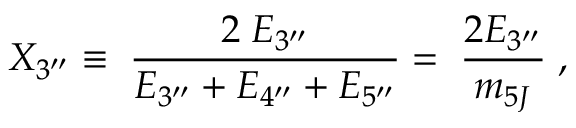<formula> <loc_0><loc_0><loc_500><loc_500>X _ { 3 ^ { \prime \prime } } \equiv \, \frac { 2 \, E _ { 3 ^ { \prime \prime } } } { E _ { 3 ^ { \prime \prime } } + E _ { 4 ^ { \prime \prime } } + E _ { 5 ^ { \prime \prime } } } = \, \frac { 2 E _ { 3 ^ { \prime \prime } } } { m _ { 5 J } } \, ,</formula> 